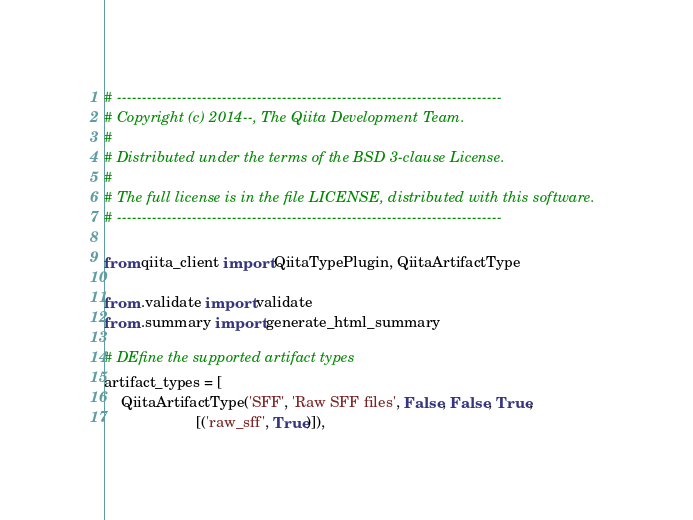<code> <loc_0><loc_0><loc_500><loc_500><_Python_># -----------------------------------------------------------------------------
# Copyright (c) 2014--, The Qiita Development Team.
#
# Distributed under the terms of the BSD 3-clause License.
#
# The full license is in the file LICENSE, distributed with this software.
# -----------------------------------------------------------------------------

from qiita_client import QiitaTypePlugin, QiitaArtifactType

from .validate import validate
from .summary import generate_html_summary

# DEfine the supported artifact types
artifact_types = [
    QiitaArtifactType('SFF', 'Raw SFF files', False, False, True,
                      [('raw_sff', True)]),</code> 